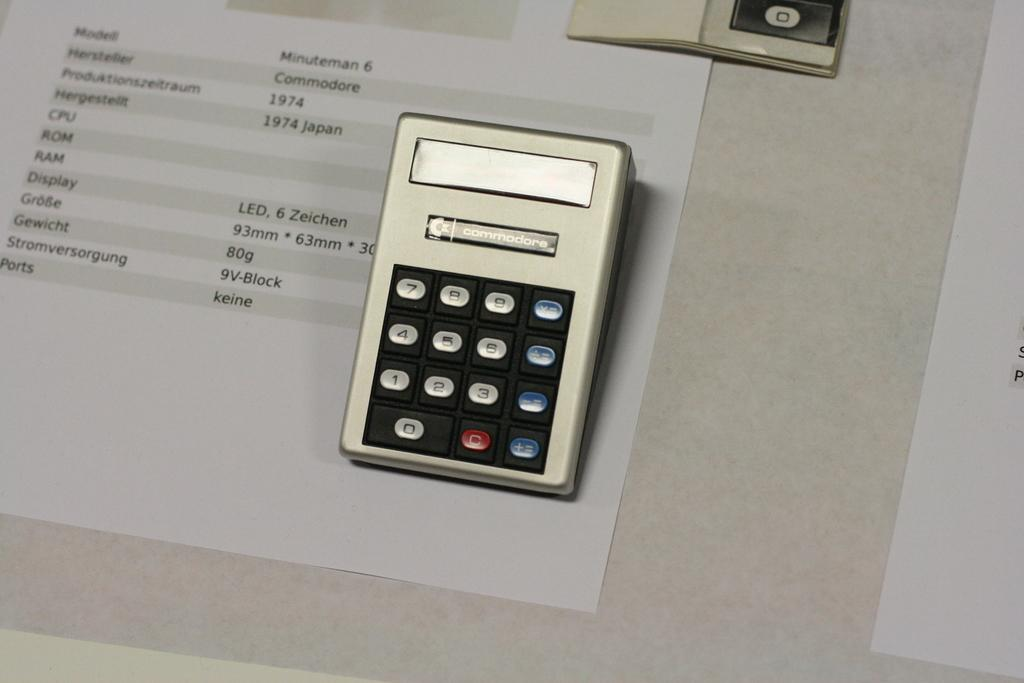<image>
Offer a succinct explanation of the picture presented. A small electronic device with the name commodore labeled across the top. 